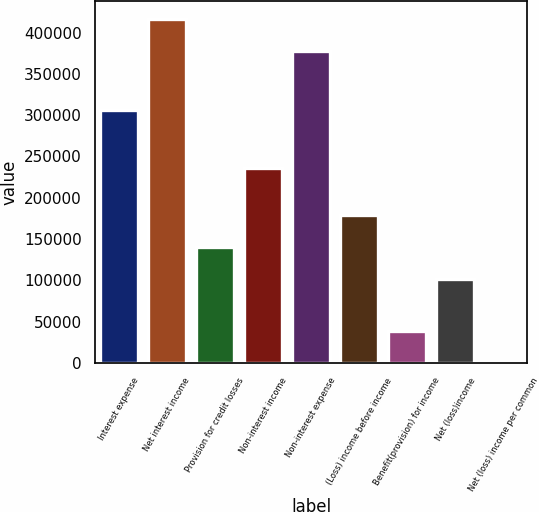<chart> <loc_0><loc_0><loc_500><loc_500><bar_chart><fcel>Interest expense<fcel>Net interest income<fcel>Provision for credit losses<fcel>Non-interest income<fcel>Non-interest expense<fcel>(Loss) income before income<fcel>Benefit(provision) for income<fcel>Net (loss)income<fcel>Net (loss) income per common<nl><fcel>306809<fcel>416790<fcel>140339<fcel>236430<fcel>377803<fcel>179325<fcel>38986.8<fcel>101352<fcel>0.25<nl></chart> 